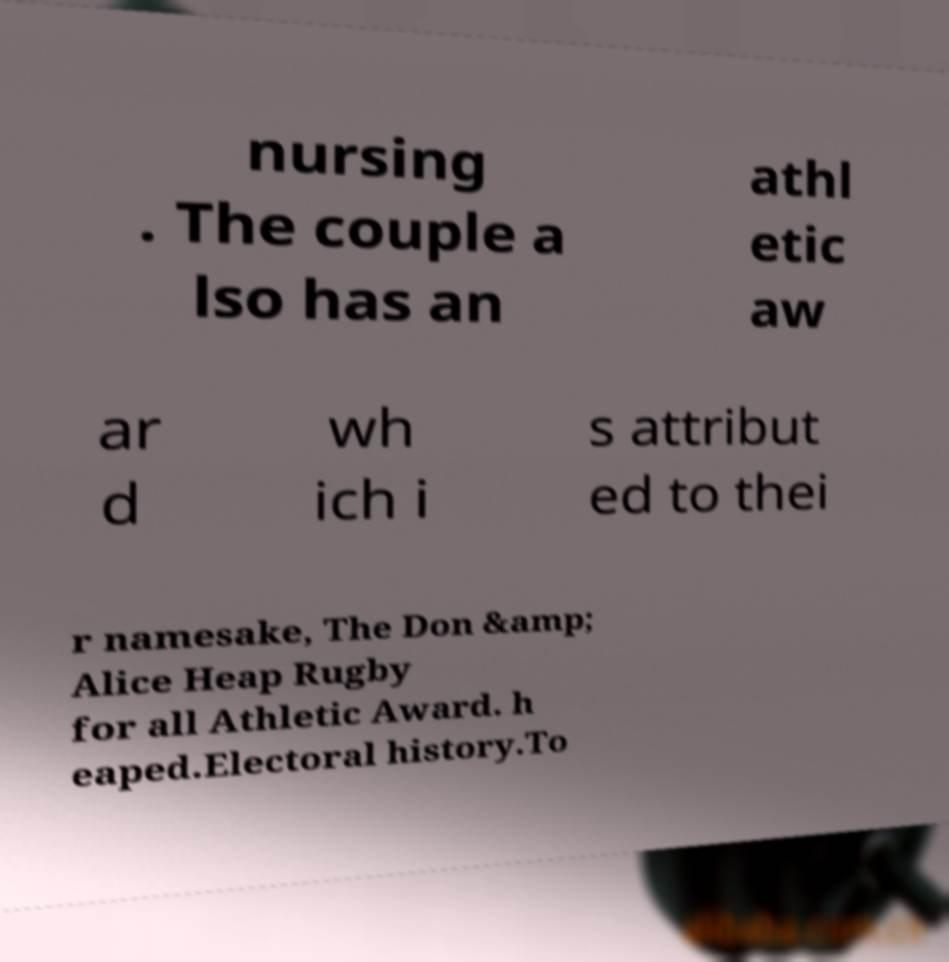Can you read and provide the text displayed in the image?This photo seems to have some interesting text. Can you extract and type it out for me? nursing . The couple a lso has an athl etic aw ar d wh ich i s attribut ed to thei r namesake, The Don &amp; Alice Heap Rugby for all Athletic Award. h eaped.Electoral history.To 